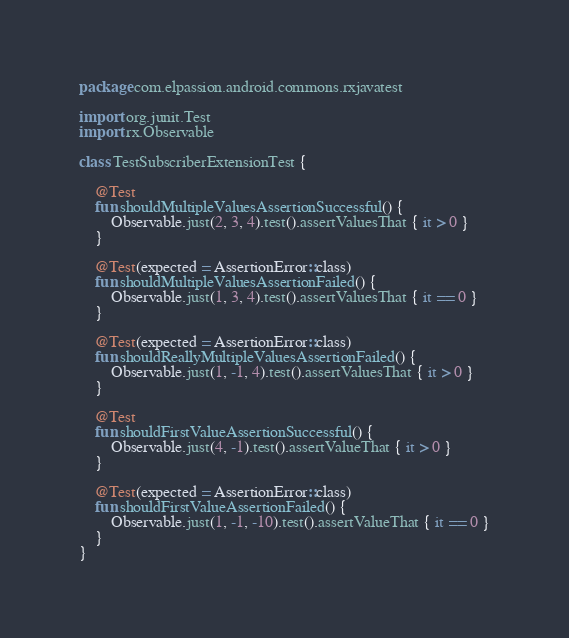Convert code to text. <code><loc_0><loc_0><loc_500><loc_500><_Kotlin_>package com.elpassion.android.commons.rxjavatest

import org.junit.Test
import rx.Observable

class TestSubscriberExtensionTest {

    @Test
    fun shouldMultipleValuesAssertionSuccessful() {
        Observable.just(2, 3, 4).test().assertValuesThat { it > 0 }
    }

    @Test(expected = AssertionError::class)
    fun shouldMultipleValuesAssertionFailed() {
        Observable.just(1, 3, 4).test().assertValuesThat { it == 0 }
    }

    @Test(expected = AssertionError::class)
    fun shouldReallyMultipleValuesAssertionFailed() {
        Observable.just(1, -1, 4).test().assertValuesThat { it > 0 }
    }

    @Test
    fun shouldFirstValueAssertionSuccessful() {
        Observable.just(4, -1).test().assertValueThat { it > 0 }
    }

    @Test(expected = AssertionError::class)
    fun shouldFirstValueAssertionFailed() {
        Observable.just(1, -1, -10).test().assertValueThat { it == 0 }
    }
}</code> 